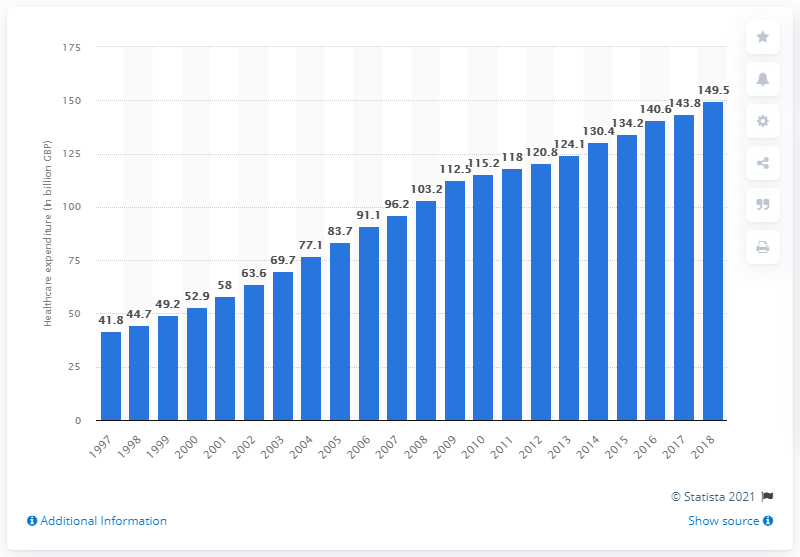Point out several critical features in this image. In 2018, the total amount of public healthcare expenditure in the United Kingdom was 149.5 billion pounds. 